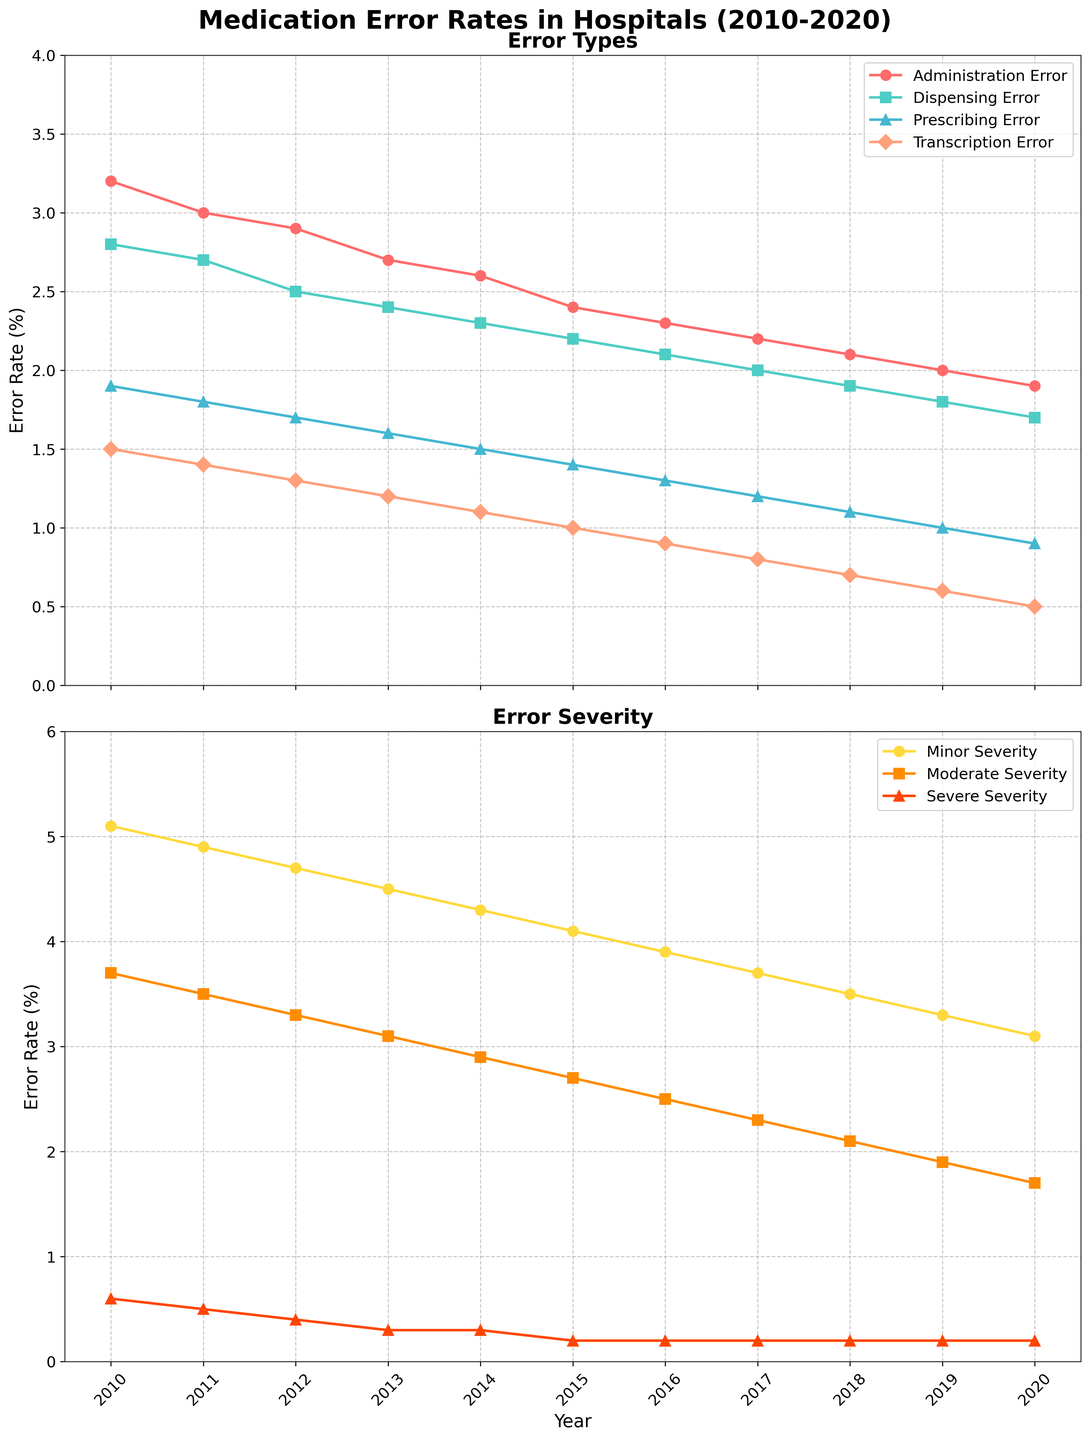What was the highest error rate for Administration Errors? By looking at the chart, we can see the Administration Error line reaches its peak at 3.2% in 2010.
Answer: 3.2% Which year had the lowest Prescribing Error rate? Observing the Prescribing Error line, we see it hits the lowest point at 0.9% in 2020.
Answer: 2020 What is the overall trend for Dispensing Errors from 2010 to 2020? The Dispensing Error line shows a consistent decrease in error rates from 2.8% in 2010 to 1.7% in 2020.
Answer: Decreasing Compare the error rates of Minor Severity and Severe Severity in 2012. In 2012, Minor Severity and Severe Severity rates were 4.7% and 0.4% respectively. Minor Severity was significantly higher than Severe Severity.
Answer: Minor Severity > Severe Severity What is the total combined error rate of Transcription Errors in 2015 and 2016? The Transcription Errors for 2015 is 1.0% and for 2016 is 0.9%. Adding them gives a total of 1.0 + 0.9 = 1.9%.
Answer: 1.9% Which error type witnessed the most significant decline from 2010 to 2020? The lines for all error types show declines, but Administration Errors dropped from 3.2% in 2010 to 1.9% in 2020, which is the largest decline of 1.3%.
Answer: Administration Error Compare the error rates for Moderate Severity in 2013 and 2018. In 2013, Moderate Severity was at 3.1% while in 2018 it was 2.1%. This shows a decrease of 1.0%.
Answer: 3.1% in 2013 and 2.1% in 2018 How did the rates for Minor Severity change between 2010 and 2020? Minor Severity shows a decreasing trend from 5.1% in 2010 to 3.1% in 2020, indicating a reduction of 2.0%.
Answer: Decreasing In which year did Severe Severity reach its lowest value? The Severe Severity line shows the lowest value in 2015, 2016, 2017, 2018, 2019, and 2020, all at 0.2%.
Answer: 2015-2020 